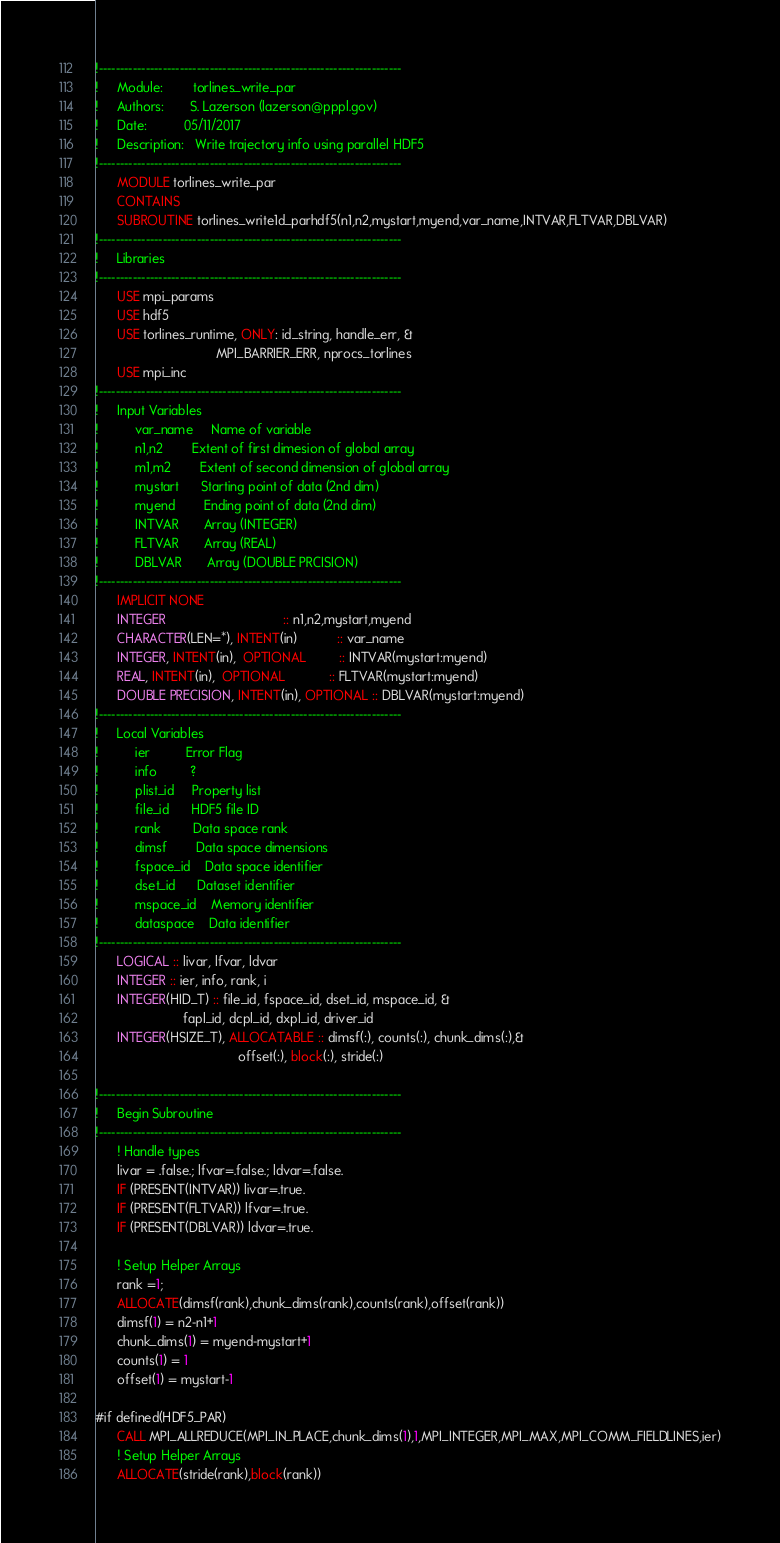<code> <loc_0><loc_0><loc_500><loc_500><_FORTRAN_>!-----------------------------------------------------------------------
!     Module:        torlines_write_par
!     Authors:       S. Lazerson (lazerson@pppl.gov)
!     Date:          05/11/2017
!     Description:   Write trajectory info using parallel HDF5
!-----------------------------------------------------------------------
      MODULE torlines_write_par
      CONTAINS
      SUBROUTINE torlines_write1d_parhdf5(n1,n2,mystart,myend,var_name,INTVAR,FLTVAR,DBLVAR)
!-----------------------------------------------------------------------
!     Libraries
!-----------------------------------------------------------------------
      USE mpi_params
      USE hdf5
      USE torlines_runtime, ONLY: id_string, handle_err, &
                                 MPI_BARRIER_ERR, nprocs_torlines
      USE mpi_inc
!-----------------------------------------------------------------------
!     Input Variables
!          var_name     Name of variable
!          n1,n2        Extent of first dimesion of global array
!          m1,m2        Extent of second dimension of global array
!          mystart      Starting point of data (2nd dim)
!          myend        Ending point of data (2nd dim)
!          INTVAR       Array (INTEGER)
!          FLTVAR       Array (REAL)
!          DBLVAR       Array (DOUBLE PRCISION)
!-----------------------------------------------------------------------
      IMPLICIT NONE
      INTEGER                                :: n1,n2,mystart,myend
      CHARACTER(LEN=*), INTENT(in)           :: var_name
      INTEGER, INTENT(in),  OPTIONAL         :: INTVAR(mystart:myend)
      REAL, INTENT(in),  OPTIONAL            :: FLTVAR(mystart:myend)
      DOUBLE PRECISION, INTENT(in), OPTIONAL :: DBLVAR(mystart:myend)
!-----------------------------------------------------------------------
!     Local Variables
!          ier          Error Flag
!          info         ?
!          plist_id     Property list
!          file_id      HDF5 file ID
!          rank         Data space rank
!          dimsf        Data space dimensions
!          fspace_id    Data space identifier
!          dset_id      Dataset identifier
!          mspace_id    Memory identifier
!          dataspace    Data identifier
!-----------------------------------------------------------------------
      LOGICAL :: livar, lfvar, ldvar
      INTEGER :: ier, info, rank, i
      INTEGER(HID_T) :: file_id, fspace_id, dset_id, mspace_id, &
                        fapl_id, dcpl_id, dxpl_id, driver_id
      INTEGER(HSIZE_T), ALLOCATABLE :: dimsf(:), counts(:), chunk_dims(:),&
                                       offset(:), block(:), stride(:)

!-----------------------------------------------------------------------
!     Begin Subroutine
!-----------------------------------------------------------------------
      ! Handle types
      livar = .false.; lfvar=.false.; ldvar=.false.
      IF (PRESENT(INTVAR)) livar=.true.
      IF (PRESENT(FLTVAR)) lfvar=.true.
      IF (PRESENT(DBLVAR)) ldvar=.true.

      ! Setup Helper Arrays
      rank =1;
      ALLOCATE(dimsf(rank),chunk_dims(rank),counts(rank),offset(rank))
      dimsf(1) = n2-n1+1
      chunk_dims(1) = myend-mystart+1
      counts(1) = 1
      offset(1) = mystart-1

#if defined(HDF5_PAR)
      CALL MPI_ALLREDUCE(MPI_IN_PLACE,chunk_dims(1),1,MPI_INTEGER,MPI_MAX,MPI_COMM_FIELDLINES,ier)
      ! Setup Helper Arrays
      ALLOCATE(stride(rank),block(rank))</code> 